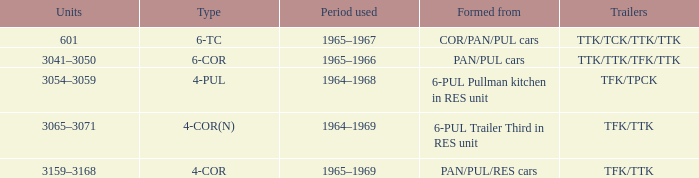What is the third type created from a 6-pul trailer in the res unit? 4-COR(N). 